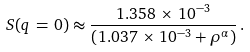Convert formula to latex. <formula><loc_0><loc_0><loc_500><loc_500>S ( q \, = \, 0 ) \approx \frac { 1 . 3 5 8 \, \times \, 1 0 ^ { - 3 } } { \left ( 1 . 0 3 7 \, \times \, 1 0 ^ { - 3 } + \rho ^ { \alpha } \right ) } \, .</formula> 